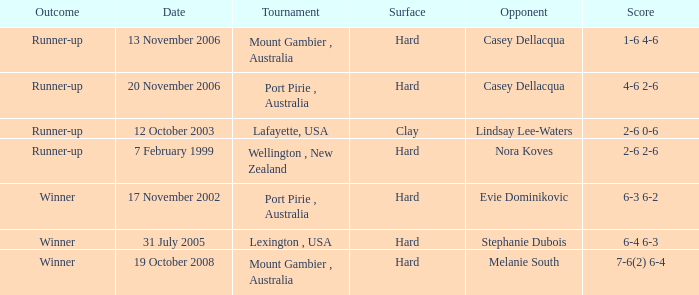Can you give me this table as a dict? {'header': ['Outcome', 'Date', 'Tournament', 'Surface', 'Opponent', 'Score'], 'rows': [['Runner-up', '13 November 2006', 'Mount Gambier , Australia', 'Hard', 'Casey Dellacqua', '1-6 4-6'], ['Runner-up', '20 November 2006', 'Port Pirie , Australia', 'Hard', 'Casey Dellacqua', '4-6 2-6'], ['Runner-up', '12 October 2003', 'Lafayette, USA', 'Clay', 'Lindsay Lee-Waters', '2-6 0-6'], ['Runner-up', '7 February 1999', 'Wellington , New Zealand', 'Hard', 'Nora Koves', '2-6 2-6'], ['Winner', '17 November 2002', 'Port Pirie , Australia', 'Hard', 'Evie Dominikovic', '6-3 6-2'], ['Winner', '31 July 2005', 'Lexington , USA', 'Hard', 'Stephanie Dubois', '6-4 6-3'], ['Winner', '19 October 2008', 'Mount Gambier , Australia', 'Hard', 'Melanie South', '7-6(2) 6-4']]} What result does an adversary of lindsay lee-waters have? Runner-up. 